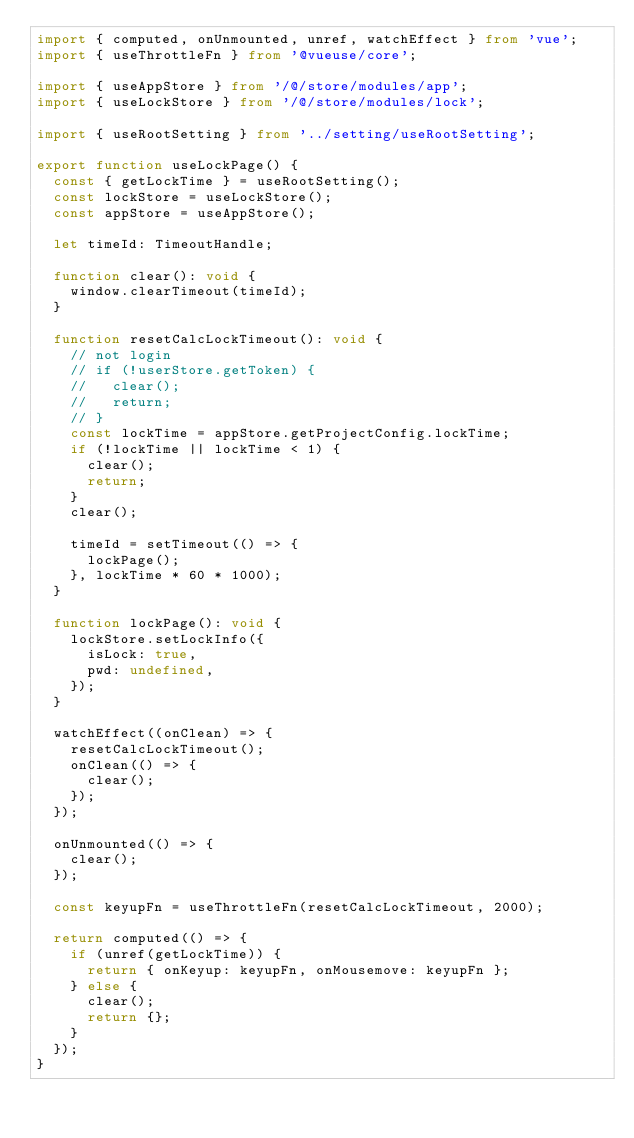<code> <loc_0><loc_0><loc_500><loc_500><_TypeScript_>import { computed, onUnmounted, unref, watchEffect } from 'vue';
import { useThrottleFn } from '@vueuse/core';

import { useAppStore } from '/@/store/modules/app';
import { useLockStore } from '/@/store/modules/lock';

import { useRootSetting } from '../setting/useRootSetting';

export function useLockPage() {
  const { getLockTime } = useRootSetting();
  const lockStore = useLockStore();
  const appStore = useAppStore();

  let timeId: TimeoutHandle;

  function clear(): void {
    window.clearTimeout(timeId);
  }

  function resetCalcLockTimeout(): void {
    // not login
    // if (!userStore.getToken) {
    //   clear();
    //   return;
    // }
    const lockTime = appStore.getProjectConfig.lockTime;
    if (!lockTime || lockTime < 1) {
      clear();
      return;
    }
    clear();

    timeId = setTimeout(() => {
      lockPage();
    }, lockTime * 60 * 1000);
  }

  function lockPage(): void {
    lockStore.setLockInfo({
      isLock: true,
      pwd: undefined,
    });
  }

  watchEffect((onClean) => {
    resetCalcLockTimeout();
    onClean(() => {
      clear();
    });
  });

  onUnmounted(() => {
    clear();
  });

  const keyupFn = useThrottleFn(resetCalcLockTimeout, 2000);

  return computed(() => {
    if (unref(getLockTime)) {
      return { onKeyup: keyupFn, onMousemove: keyupFn };
    } else {
      clear();
      return {};
    }
  });
}
</code> 